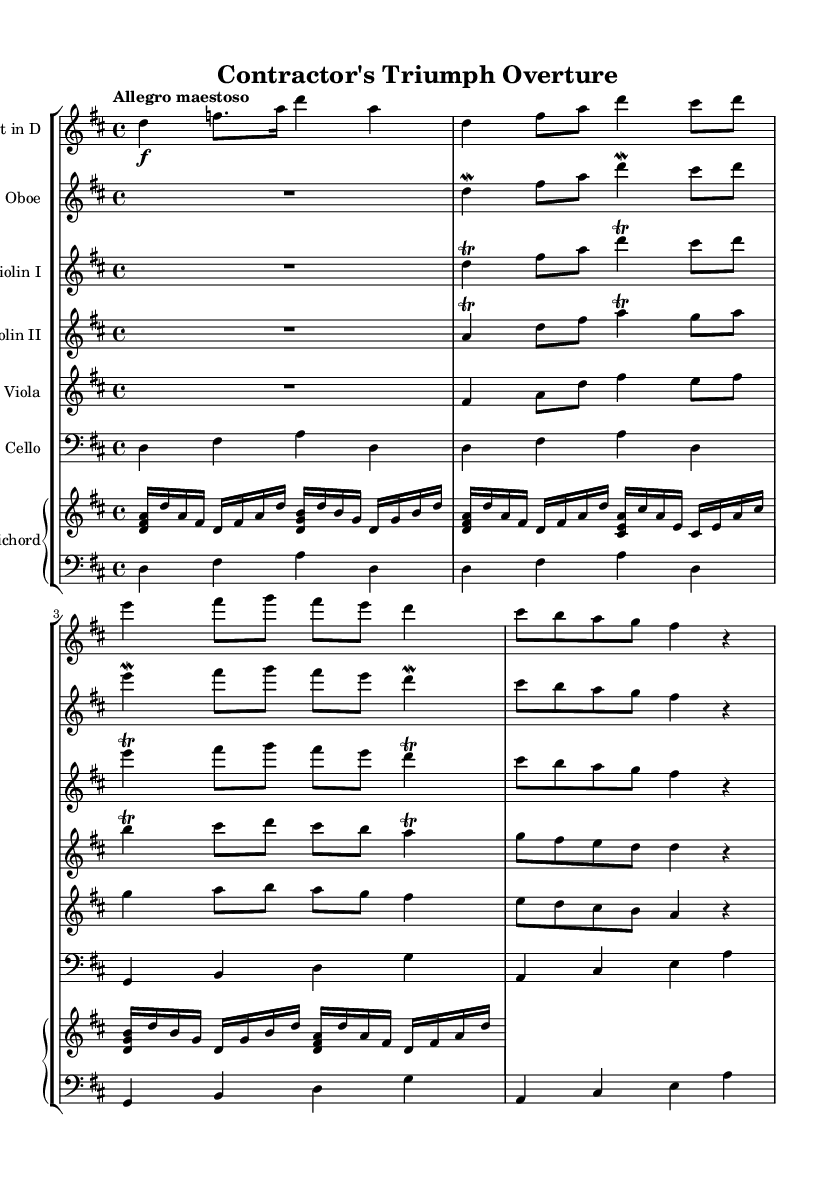What is the key signature of this music? The key signature is indicated by the number of sharps or flats at the beginning of the staff. Here, there is an F# and a C#, meaning the key signature is D major.
Answer: D major What is the time signature? The time signature is found at the beginning of the staff, represented by two numbers. Here, it shows 4 over 4, meaning there are four beats per measure and each quarter note gets one beat.
Answer: 4/4 What is the tempo marking for this piece? The tempo marking is indicated at the beginning of the music. It states "Allegro maestoso," which means to play fast and majestically.
Answer: Allegro maestoso How many measures are there in the trumpet part? By counting the distinct sections of the music, we can find all the measures. In the trumpet part, there are a total of four measures.
Answer: 4 Which instrument plays the main theme with trills? Looking at the various instruments, it's the Violin I that specifically has markings for trills while presenting the main theme.
Answer: Violin I Is there a specific musical ornament featured prominently in this sheet music? Several ornaments are used throughout, but a consistent ornament present in multiple parts is the trill, especially noted in Violin I and Violin II.
Answer: Trill What instrument provides the bass line in this piece? The bass line is typically provided by the cello, as indicated by its part located at the lower staff with a bass clef.
Answer: Cello 